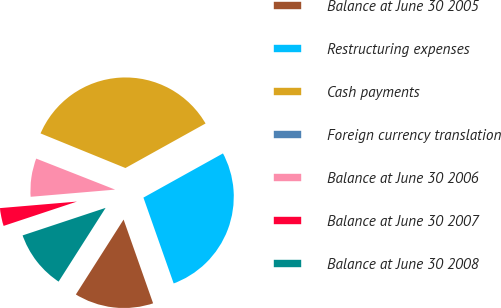<chart> <loc_0><loc_0><loc_500><loc_500><pie_chart><fcel>Balance at June 30 2005<fcel>Restructuring expenses<fcel>Cash payments<fcel>Foreign currency translation<fcel>Balance at June 30 2006<fcel>Balance at June 30 2007<fcel>Balance at June 30 2008<nl><fcel>14.42%<fcel>27.68%<fcel>35.76%<fcel>0.2%<fcel>7.31%<fcel>3.75%<fcel>10.87%<nl></chart> 